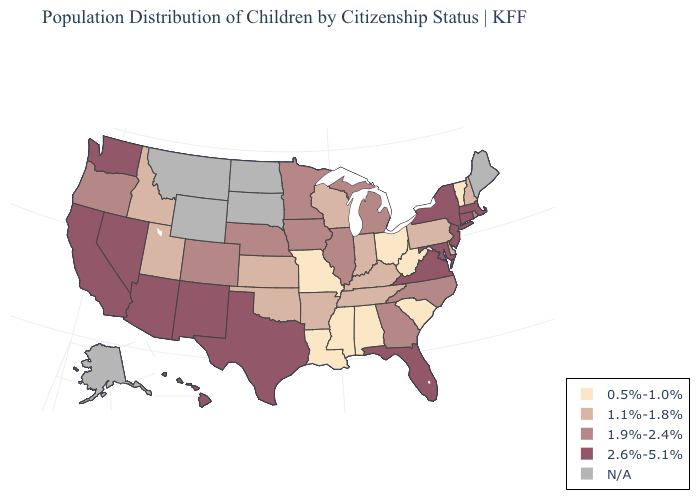Is the legend a continuous bar?
Concise answer only. No. What is the value of Kentucky?
Give a very brief answer. 1.1%-1.8%. Does Vermont have the lowest value in the USA?
Be succinct. Yes. Name the states that have a value in the range 2.6%-5.1%?
Be succinct. Arizona, California, Connecticut, Florida, Hawaii, Maryland, Massachusetts, Nevada, New Jersey, New Mexico, New York, Texas, Virginia, Washington. Which states have the lowest value in the West?
Write a very short answer. Idaho, Utah. What is the value of Oklahoma?
Write a very short answer. 1.1%-1.8%. Name the states that have a value in the range 1.1%-1.8%?
Short answer required. Arkansas, Delaware, Idaho, Indiana, Kansas, Kentucky, New Hampshire, Oklahoma, Pennsylvania, Tennessee, Utah, Wisconsin. Name the states that have a value in the range 1.9%-2.4%?
Keep it brief. Colorado, Georgia, Illinois, Iowa, Michigan, Minnesota, Nebraska, North Carolina, Oregon, Rhode Island. Which states have the lowest value in the Northeast?
Short answer required. Vermont. Does Utah have the lowest value in the West?
Short answer required. Yes. Name the states that have a value in the range 1.1%-1.8%?
Concise answer only. Arkansas, Delaware, Idaho, Indiana, Kansas, Kentucky, New Hampshire, Oklahoma, Pennsylvania, Tennessee, Utah, Wisconsin. Name the states that have a value in the range 0.5%-1.0%?
Keep it brief. Alabama, Louisiana, Mississippi, Missouri, Ohio, South Carolina, Vermont, West Virginia. What is the value of Minnesota?
Short answer required. 1.9%-2.4%. What is the highest value in the USA?
Answer briefly. 2.6%-5.1%. What is the value of New Mexico?
Keep it brief. 2.6%-5.1%. 